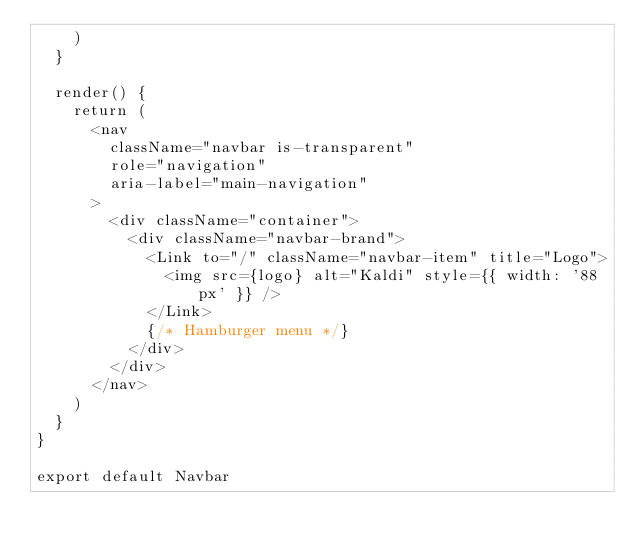Convert code to text. <code><loc_0><loc_0><loc_500><loc_500><_JavaScript_>    )
  }

  render() {
    return (
      <nav
        className="navbar is-transparent"
        role="navigation"
        aria-label="main-navigation"
      >
        <div className="container">
          <div className="navbar-brand">
            <Link to="/" className="navbar-item" title="Logo">
              <img src={logo} alt="Kaldi" style={{ width: '88px' }} />
            </Link>
            {/* Hamburger menu */}
          </div>
        </div>
      </nav>
    )
  }
}

export default Navbar
</code> 